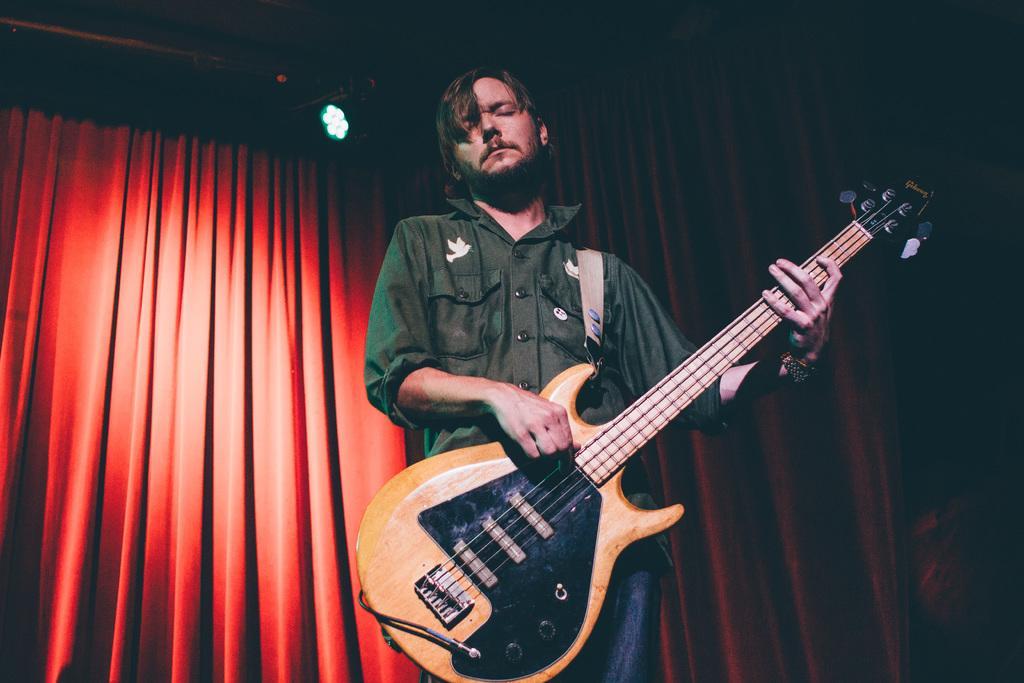How would you summarize this image in a sentence or two? Here in this picture we can see a man is playing a guitar. He is wearing a green shirt. In the back there is red curtain. 